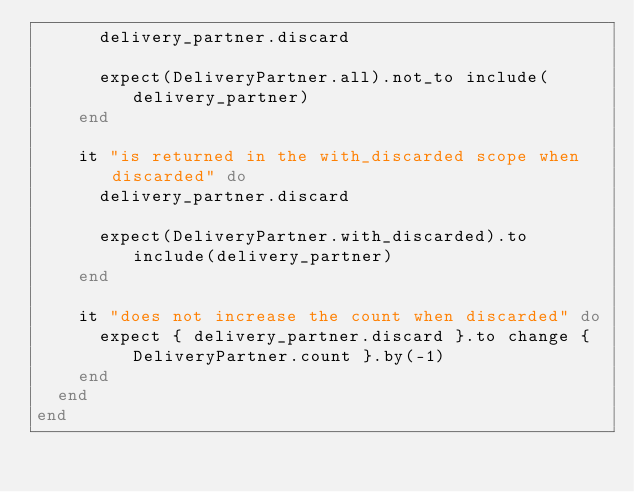<code> <loc_0><loc_0><loc_500><loc_500><_Ruby_>      delivery_partner.discard

      expect(DeliveryPartner.all).not_to include(delivery_partner)
    end

    it "is returned in the with_discarded scope when discarded" do
      delivery_partner.discard

      expect(DeliveryPartner.with_discarded).to include(delivery_partner)
    end

    it "does not increase the count when discarded" do
      expect { delivery_partner.discard }.to change { DeliveryPartner.count }.by(-1)
    end
  end
end
</code> 